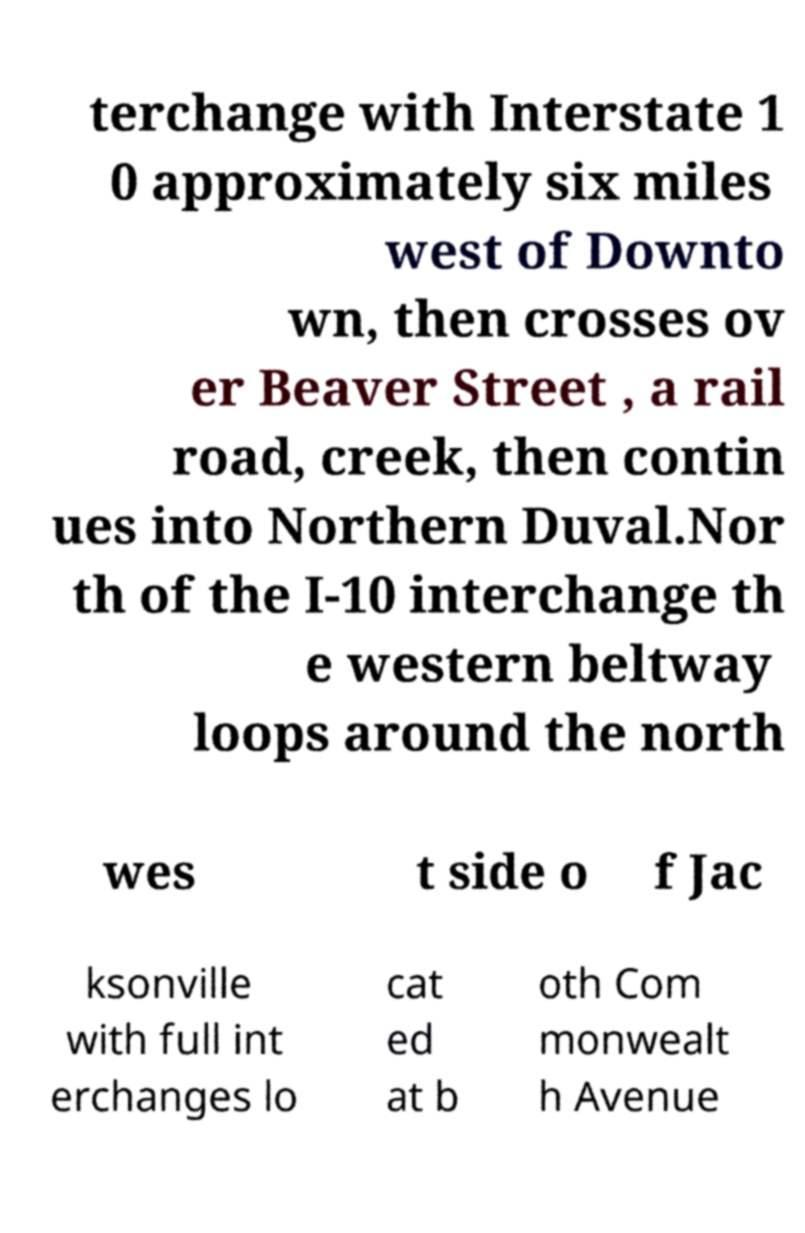Can you read and provide the text displayed in the image?This photo seems to have some interesting text. Can you extract and type it out for me? terchange with Interstate 1 0 approximately six miles west of Downto wn, then crosses ov er Beaver Street , a rail road, creek, then contin ues into Northern Duval.Nor th of the I-10 interchange th e western beltway loops around the north wes t side o f Jac ksonville with full int erchanges lo cat ed at b oth Com monwealt h Avenue 